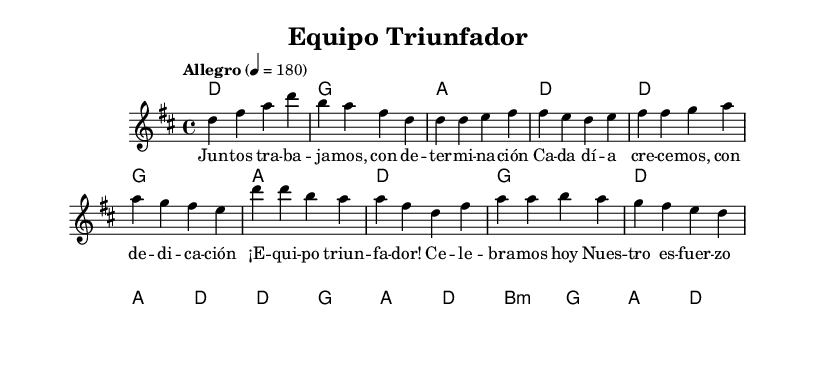What is the key signature of this music? The key signature is indicated by the `\key` command in the code, which is set to D major. D major has two sharps: F# and C#.
Answer: D major What is the time signature of the music? The time signature is specified by the `\time` command in the code, which is set to 4/4. This means there are four beats per measure, and each quarter note gets one beat.
Answer: 4/4 What is the tempo marking of this piece? The tempo marking is defined by the `\tempo` command. Here, it is set to "Allegro" at a speed of 180 beats per minute, indicating a fast tempo.
Answer: Allegro 180 How many measures are in the chorus? To determine the number of measures in the chorus, we count the music notation in the chorus section labeled by `\chorus`. The chorus has two measures, represented by the musical notation provided.
Answer: 2 Which section celebrates the team's achievements? The section labeled as `\chorus` contains lyrics that celebrate teamwork and success, specifically "¡Equipo triunfador! Celebramos hoy". This section expresses joy and recognition of the team's achievements.
Answer: chorus What is the overall mood conveyed by the tempo and lyrics? The mood is energetic and celebratory, indicated by the fast tempo (180) and uplifting lyrics focusing on teamwork and success. This aligns with typical characteristics of salsa music that often highlights positive themes.
Answer: energetic and celebratory 